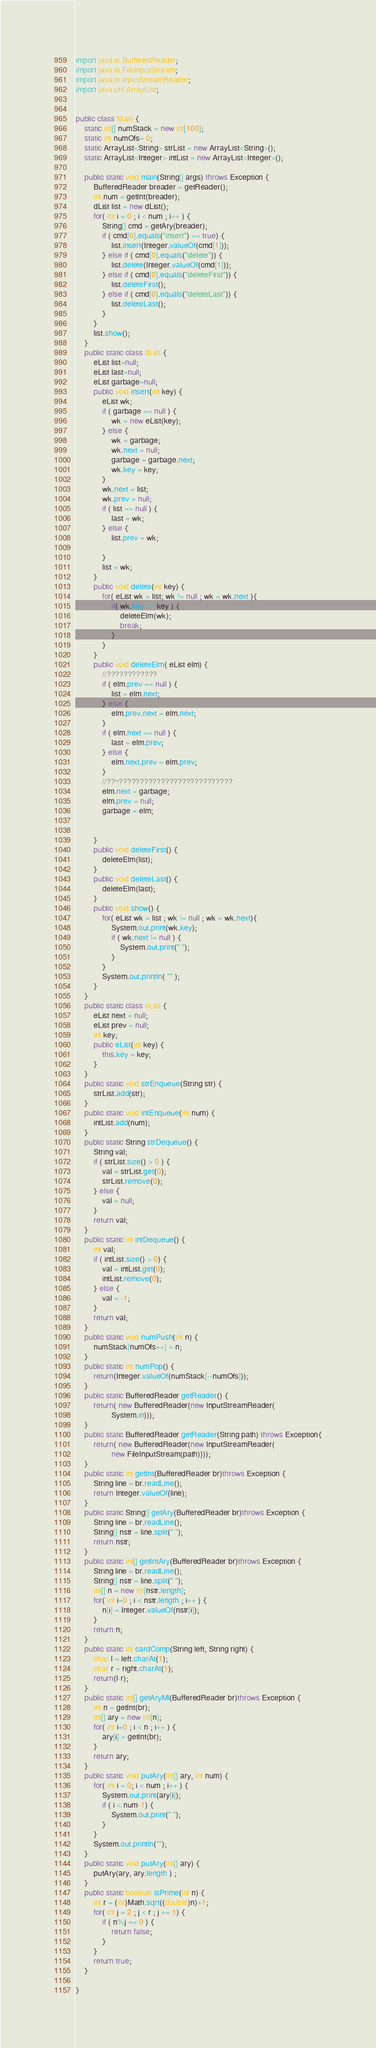<code> <loc_0><loc_0><loc_500><loc_500><_Java_>import java.io.BufferedReader;
import java.io.FileInputStream;
import java.io.InputStreamReader;
import java.util.ArrayList;


public class Main {
	static int[] numStack = new int[100];
	static int numOfs= 0;
	static ArrayList<String> strList = new ArrayList<String>();
	static ArrayList<Integer> intList = new ArrayList<Integer>();

	public static void main(String[] args) throws Exception {
		BufferedReader breader = getReader();
		int num = getInt(breader);
		dList list = new dList();
		for( int i = 0 ; i < num ; i++ ) {
			String[] cmd = getAry(breader);
			if ( cmd[0].equals("insert") == true) {
				list.insert(Integer.valueOf(cmd[1]));
			} else if ( cmd[0].equals("delete")) {
				list.delete(Integer.valueOf(cmd[1]));
			} else if ( cmd[0].equals("deleteFirst")) {
				list.deleteFirst();
			} else if ( cmd[0].equals("deleteLast")) {
				list.deleteLast();
			}
		}
		list.show();
	}
	public static class dList {
		eList list=null;
		eList last=null;
		eList garbage=null;
		public void insert(int key) {
			eList wk;
			if ( garbage == null ) {
				wk = new eList(key);
			} else {
				wk = garbage;
				wk.next = null;
				garbage = garbage.next;
				wk.key = key;
			}
			wk.next = list;
			wk.prev = null;
			if ( list == null ) {
				last = wk;
			} else {
				list.prev = wk;
			
			}
			list = wk;
		}
		public void delete(int key) {
			for( eList wk = list; wk != null ; wk = wk.next ){
				if( wk.key == key ) {
					deleteElm(wk);
					break;
				}
			}
		}
		public void deleteElm( eList elm) {
			//????????????
			if ( elm.prev == null ) {
				list = elm.next;
			} else {
				elm.prev.next = elm.next;
			}
			if ( elm.next == null ) {
				last = elm.prev;
			} else {
				elm.next.prev = elm.prev;
			}
			//??¬???????????????????????????
			elm.next = garbage;
			elm.prev = null;
			garbage = elm;
			
		
		}
		public void deleteFirst() {
			deleteElm(list);
		}
		public void deleteLast() {
			deleteElm(last);
		}
		public void show() {
			for( eList wk = list ; wk != null ; wk = wk.next){
				System.out.print(wk.key);
				if ( wk.next != null ) {
					System.out.print(" ");
				}
			}
			System.out.println( "" );
		}
	}
	public static class eList {
		eList next = null;
		eList prev = null;
		int key;
		public eList(int key) {
			this.key = key;
		}
	}
	public static void strEnqueue(String str) {
		strList.add(str);
	}
	public static void intEnqueue(int num) {
		intList.add(num);
	}
	public static String strDequeue() {
		String val;
		if ( strList.size() > 0 ) {
			val = strList.get(0);
			strList.remove(0);
		} else {
			val = null;
		}
		return val;
	}
	public static int intDequeue() {
		int val;
		if ( intList.size() > 0) {
			val = intList.get(0);
			intList.remove(0);
		} else {
			val = -1;
		}
		return val;
	}
	public static void numPush(int n) {
		numStack[numOfs++] = n;
	}
	public static int numPop() {
		return(Integer.valueOf(numStack[--numOfs]));
	}
	public static BufferedReader getReader() {
		return( new BufferedReader(new InputStreamReader(
				System.in)));
	}
	public static BufferedReader getReader(String path) throws Exception{
		return( new BufferedReader(new InputStreamReader(
				new FileInputStream(path))));
	}
	public static int getInt(BufferedReader br)throws Exception {
		String line = br.readLine();
		return Integer.valueOf(line);
	}
	public static String[] getAry(BufferedReader br)throws Exception {
		String line = br.readLine();
		String[] nstr = line.split(" ");
		return nstr;
	}
	public static int[] getIntAry(BufferedReader br)throws Exception {
		String line = br.readLine();
		String[] nstr = line.split(" ");
		int[] n = new int[nstr.length];
		for( int i=0 ; i < nstr.length ; i++ ) {
			n[i] = Integer.valueOf(nstr[i]);
		}
		return n;
	}
	public static int cardComp(String left, String right) {
		char l = left.charAt(1);
		char r = right.charAt(1);
		return(l-r);
	}
	public static int[] getAryMl(BufferedReader br)throws Exception {
		int n = getInt(br);
		int[] ary = new int[n];
		for( int i=0 ; i < n ; i++ ) {
			ary[i] = getInt(br);
		}
		return ary;
	}
	public static void putAry(int[] ary, int num) {
		for( int i = 0; i < num ; i++ ) {
			System.out.print(ary[i]);
			if ( i < num-1) {
				System.out.print(" ");
			}
		}
		System.out.println("");
	}
	public static void putAry(int[] ary) {
		putAry(ary, ary.length ) ;
	}
	public static boolean isPrime(int n) {
		int r = (int)Math.sqrt((double)n)+1;
		for( int j = 2 ; j < r ; j += 1) {
			if ( n%j == 0 ) {
				return false;
			}
		}
		return true;
	}

}</code> 